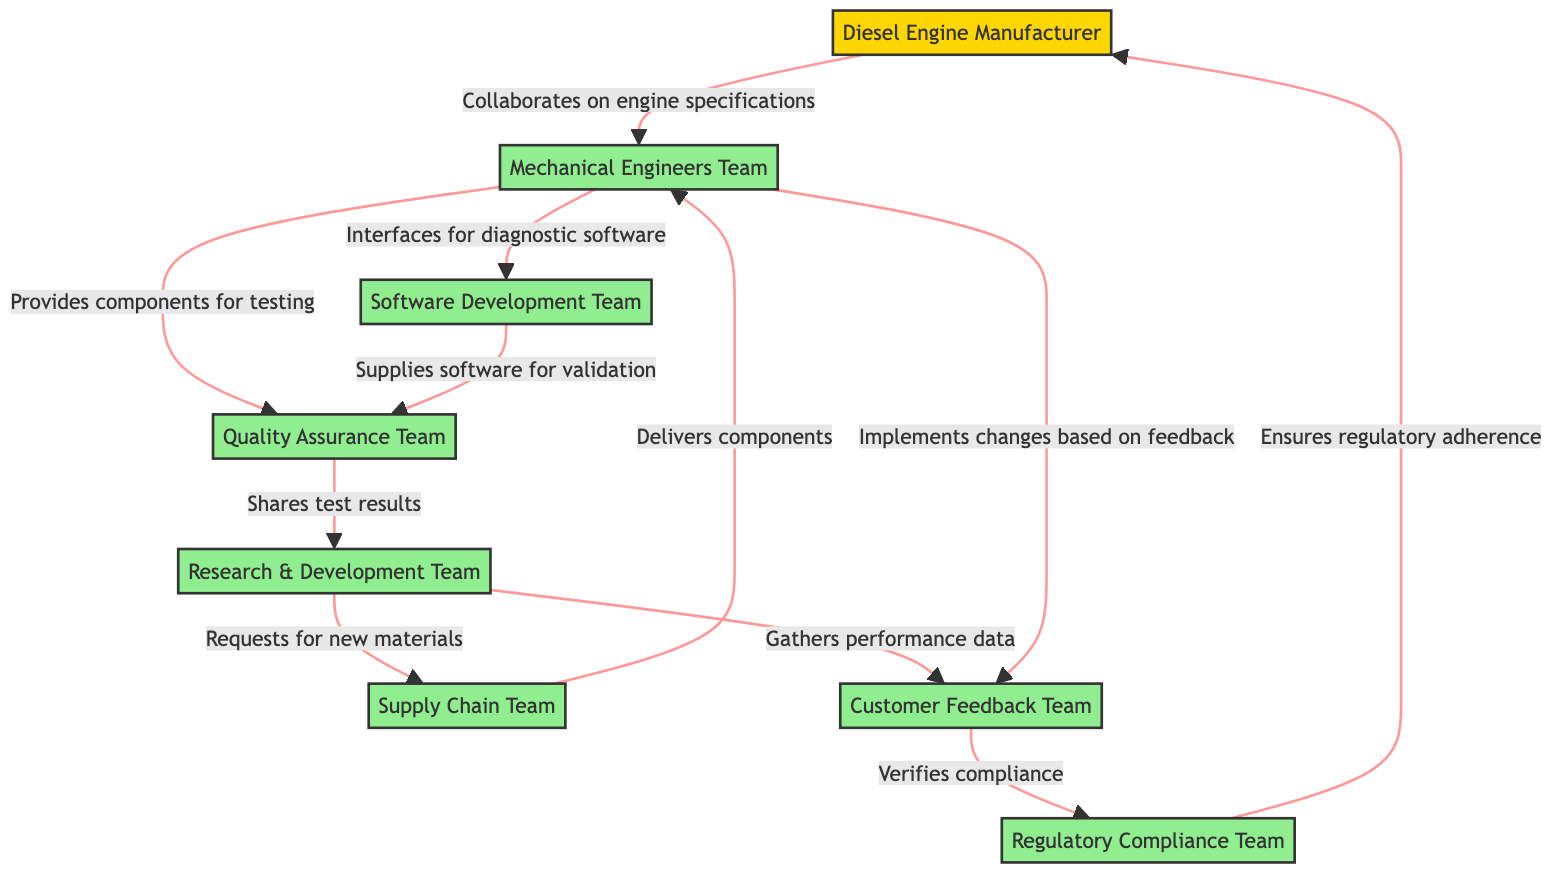What is the total number of nodes in the diagram? The diagram shows a total of 8 nodes, which include various teams and the manufacturer. These are: Diesel Engine Manufacturer, Mechanical Engineers Team, Software Development Team, Quality Assurance Team, Research & Development Team, Supply Chain Team, Customer Feedback Team, and Regulatory Compliance Team.
Answer: 8 Which team provides components for testing? The edge labeled "Provides components for testing" connects the Mechanical Engineers Team (node 2) to the Quality Assurance Team (node 4). This indicates that the Mechanical Engineers Team is responsible for providing components to the Quality Assurance Team for testing purposes.
Answer: Quality Assurance Team How many edges are present in the diagram? By counting the connections (edges) between the nodes, we can see there are 10 edges in total linking the various teams and the manufacturer, which represent the collaborative activities between them.
Answer: 10 Which team interfaces for diagnostic software? The edge labeled "Interfaces for diagnostic software" shows a direct connection from the Mechanical Engineers Team (node 2) to the Software Development Team (node 3), indicating that this is the team responsible for providing the necessary interfaces.
Answer: Software Development Team How does the Research & Development Team gather performance data? The Research & Development Team (node 5) gathers performance data from the Customer Feedback Team (node 7), as indicated by the edge labeled "Gathers performance data" connecting the two nodes. This illustrates the flow of information emphasizing the importance of user feedback in developing engine performance improvements.
Answer: Customer Feedback Team What is the relationship between the Customer Feedback Team and the Regulatory Compliance Team? There is a directed edge from the Customer Feedback Team (node 7) to the Regulatory Compliance Team (node 8) labeled "Verifies compliance." This indicates that the Customer Feedback Team communicates relevant feedback to the Regulatory Compliance Team to verify that products meet regulatory standards.
Answer: Verifies compliance Which team requests new materials? The diagram displays an edge labeled "Requests for new materials" that connects the Research & Development Team (node 5) with the Supply Chain Team (node 6). This relationship signifies that the Research & Development Team requires new materials for ongoing projects.
Answer: Supply Chain Team Who collaborates on engine specifications? There is an edge labeled "Collaborates on engine specifications" between the Diesel Engine Manufacturer (node 1) and the Mechanical Engineers Team (node 2). This connection represents the direct collaboration focused on defining the specifications needed for engine development.
Answer: Mechanical Engineers Team Which team ensures regulatory adherence? The Regulatory Compliance Team (node 8) ensures regulatory adherence by connecting back to the Diesel Engine Manufacturer (node 1) through the edge labeled "Ensures regulatory adherence." This indicates the team's responsibility in maintaining compliance with regulations that impact the manufacturer.
Answer: Diesel Engine Manufacturer 